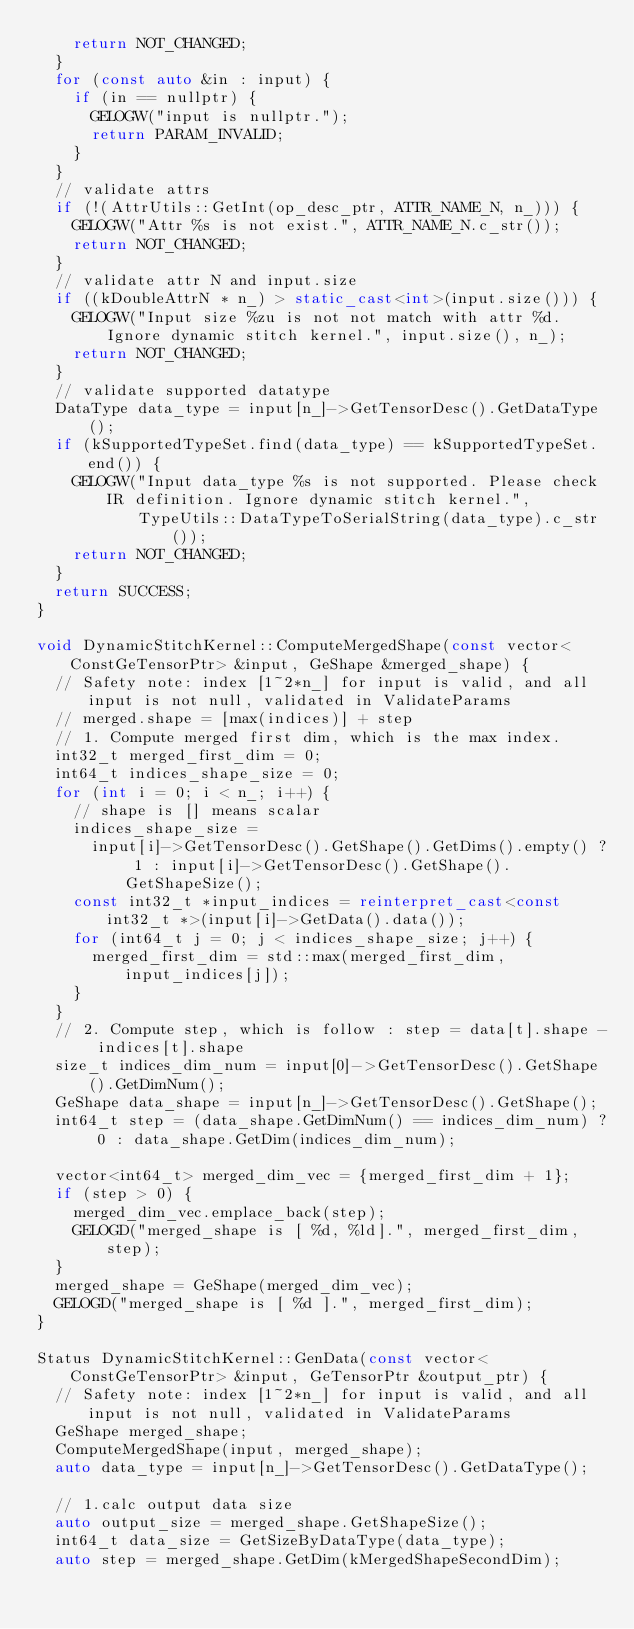<code> <loc_0><loc_0><loc_500><loc_500><_C++_>    return NOT_CHANGED;
  }
  for (const auto &in : input) {
    if (in == nullptr) {
      GELOGW("input is nullptr.");
      return PARAM_INVALID;
    }
  }
  // validate attrs
  if (!(AttrUtils::GetInt(op_desc_ptr, ATTR_NAME_N, n_))) {
    GELOGW("Attr %s is not exist.", ATTR_NAME_N.c_str());
    return NOT_CHANGED;
  }
  // validate attr N and input.size
  if ((kDoubleAttrN * n_) > static_cast<int>(input.size())) {
    GELOGW("Input size %zu is not not match with attr %d. Ignore dynamic stitch kernel.", input.size(), n_);
    return NOT_CHANGED;
  }
  // validate supported datatype
  DataType data_type = input[n_]->GetTensorDesc().GetDataType();
  if (kSupportedTypeSet.find(data_type) == kSupportedTypeSet.end()) {
    GELOGW("Input data_type %s is not supported. Please check IR definition. Ignore dynamic stitch kernel.",
           TypeUtils::DataTypeToSerialString(data_type).c_str());
    return NOT_CHANGED;
  }
  return SUCCESS;
}

void DynamicStitchKernel::ComputeMergedShape(const vector<ConstGeTensorPtr> &input, GeShape &merged_shape) {
  // Safety note: index [1~2*n_] for input is valid, and all input is not null, validated in ValidateParams
  // merged.shape = [max(indices)] + step
  // 1. Compute merged first dim, which is the max index.
  int32_t merged_first_dim = 0;
  int64_t indices_shape_size = 0;
  for (int i = 0; i < n_; i++) {
    // shape is [] means scalar
    indices_shape_size =
      input[i]->GetTensorDesc().GetShape().GetDims().empty() ? 1 : input[i]->GetTensorDesc().GetShape().GetShapeSize();
    const int32_t *input_indices = reinterpret_cast<const int32_t *>(input[i]->GetData().data());
    for (int64_t j = 0; j < indices_shape_size; j++) {
      merged_first_dim = std::max(merged_first_dim, input_indices[j]);
    }
  }
  // 2. Compute step, which is follow : step = data[t].shape - indices[t].shape
  size_t indices_dim_num = input[0]->GetTensorDesc().GetShape().GetDimNum();
  GeShape data_shape = input[n_]->GetTensorDesc().GetShape();
  int64_t step = (data_shape.GetDimNum() == indices_dim_num) ? 0 : data_shape.GetDim(indices_dim_num);

  vector<int64_t> merged_dim_vec = {merged_first_dim + 1};
  if (step > 0) {
    merged_dim_vec.emplace_back(step);
    GELOGD("merged_shape is [ %d, %ld].", merged_first_dim, step);
  }
  merged_shape = GeShape(merged_dim_vec);
  GELOGD("merged_shape is [ %d ].", merged_first_dim);
}

Status DynamicStitchKernel::GenData(const vector<ConstGeTensorPtr> &input, GeTensorPtr &output_ptr) {
  // Safety note: index [1~2*n_] for input is valid, and all input is not null, validated in ValidateParams
  GeShape merged_shape;
  ComputeMergedShape(input, merged_shape);
  auto data_type = input[n_]->GetTensorDesc().GetDataType();

  // 1.calc output data size
  auto output_size = merged_shape.GetShapeSize();
  int64_t data_size = GetSizeByDataType(data_type);
  auto step = merged_shape.GetDim(kMergedShapeSecondDim);</code> 